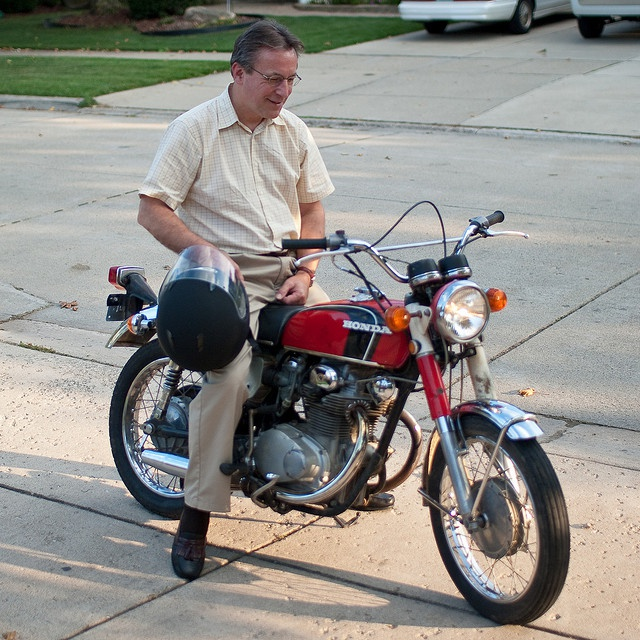Describe the objects in this image and their specific colors. I can see motorcycle in black, gray, darkgray, and lightgray tones, people in black, darkgray, lightgray, and gray tones, car in black, gray, lightblue, and darkgray tones, and car in black, gray, and darkgray tones in this image. 